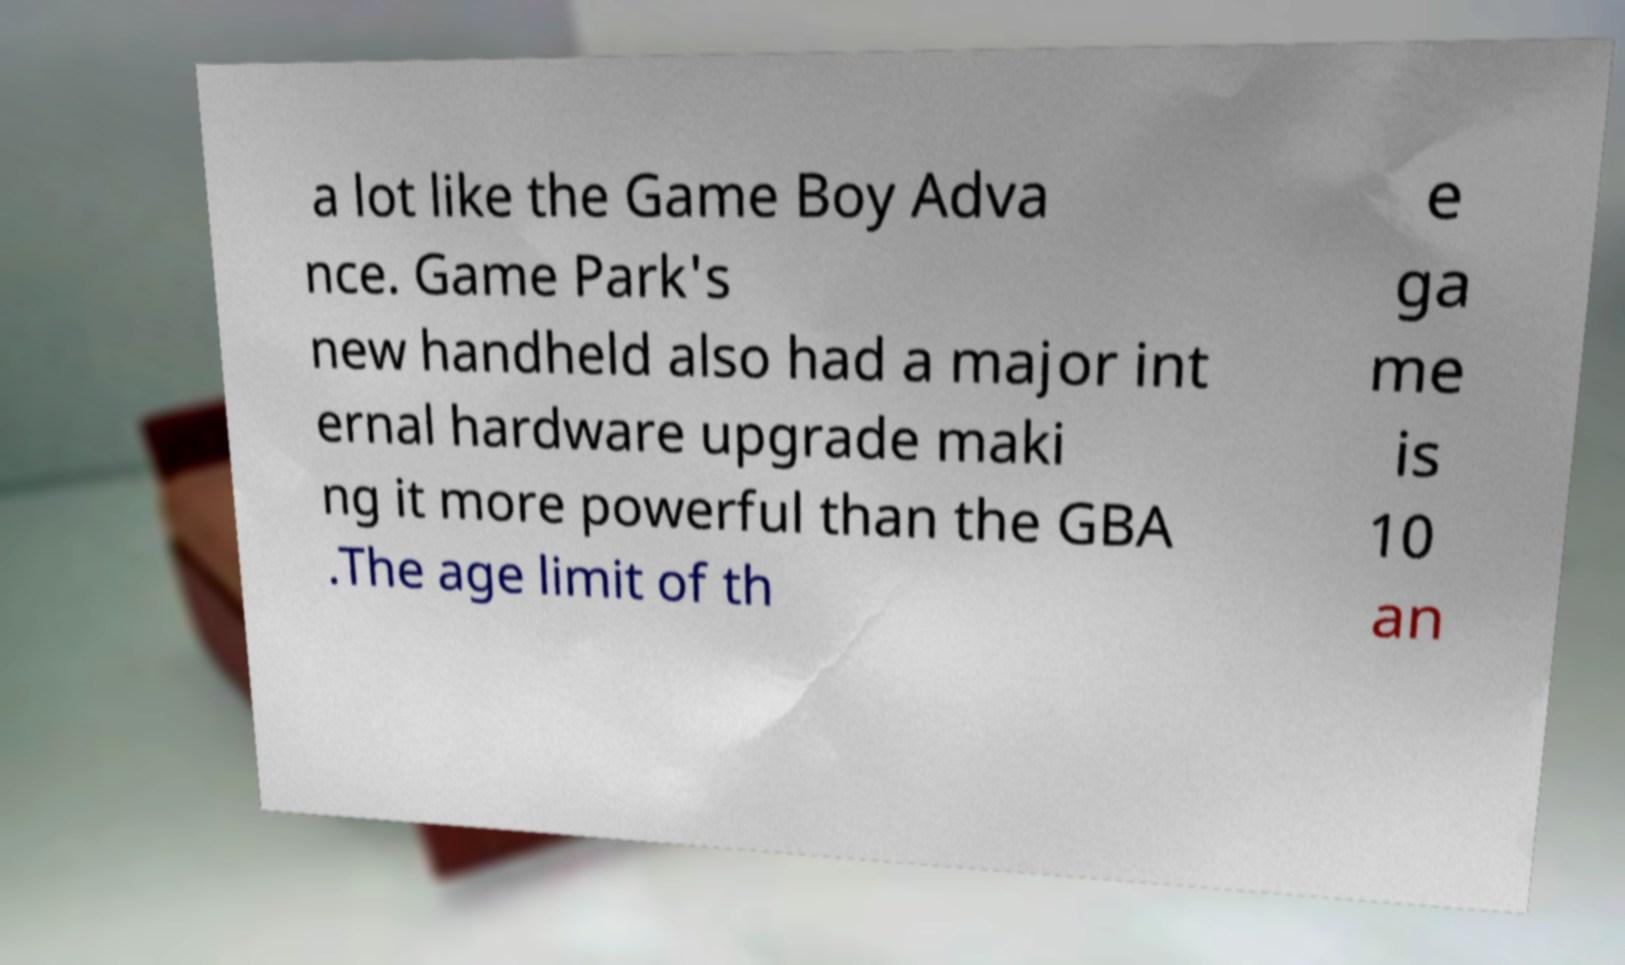Please read and relay the text visible in this image. What does it say? a lot like the Game Boy Adva nce. Game Park's new handheld also had a major int ernal hardware upgrade maki ng it more powerful than the GBA .The age limit of th e ga me is 10 an 